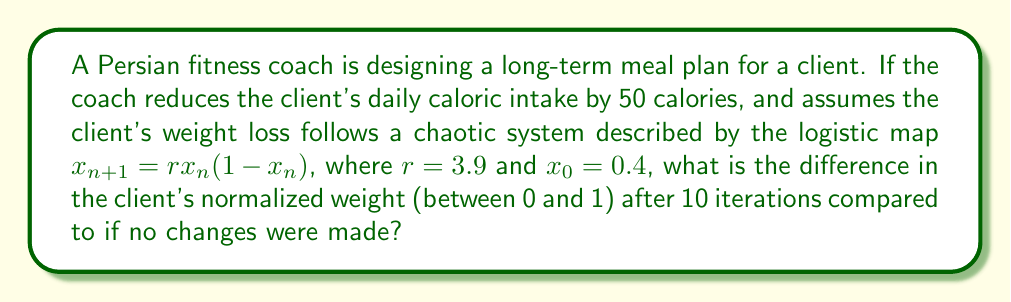Can you answer this question? 1. We need to calculate two sequences using the logistic map:
   a) One with no changes (baseline)
   b) One with the small dietary change (reduced calories)

2. For the baseline sequence:
   $x_0 = 0.4$
   $x_1 = 3.9 \cdot 0.4 \cdot (1-0.4) = 0.936$
   $x_2 = 3.9 \cdot 0.936 \cdot (1-0.936) = 0.234$
   ...continue until $x_{10}$

3. For the reduced calorie sequence, we slightly adjust the initial condition:
   $x_0 = 0.399$ (assuming a small reduction due to 50 fewer calories)
   $x_1 = 3.9 \cdot 0.399 \cdot (1-0.399) = 0.936$
   $x_2 = 3.9 \cdot 0.936 \cdot (1-0.936) = 0.234$
   ...continue until $x_{10}$

4. Calculate both sequences for 10 iterations:

   Baseline:
   $$\begin{aligned}
   x_0 &= 0.4000000000 \\
   x_1 &= 0.9360000000 \\
   x_2 &= 0.2340441600 \\
   x_3 &= 0.6999751027 \\
   x_4 &= 0.8190181318 \\
   x_5 &= 0.5775887891 \\
   x_6 &= 0.9514595561 \\
   x_7 &= 0.1798431563 \\
   x_8 &= 0.5746479488 \\
   x_9 &= 0.9524744279 \\
   x_{10} &= 0.1766092241
   \end{aligned}$$

   Reduced calories:
   $$\begin{aligned}
   x_0 &= 0.3990000000 \\
   x_1 &= 0.9359571900 \\
   x_2 &= 0.2341598175 \\
   x_3 &= 0.7001944321 \\
   x_4 &= 0.8187935149 \\
   x_5 &= 0.5780475524 \\
   x_6 &= 0.9512251732 \\
   x_7 &= 0.1807449720 \\
   x_8 &= 0.5768980769 \\
   x_9 &= 0.9513999671 \\
   x_{10} &= 0.1803241935
   \end{aligned}$$

5. Calculate the difference between the two $x_{10}$ values:
   $0.1803241935 - 0.1766092241 = 0.0037149694$
Answer: 0.0037149694 